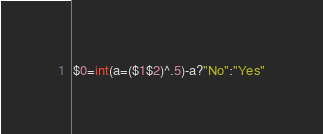<code> <loc_0><loc_0><loc_500><loc_500><_Awk_>$0=int(a=($1$2)^.5)-a?"No":"Yes"</code> 